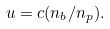Convert formula to latex. <formula><loc_0><loc_0><loc_500><loc_500>u = c ( n _ { b } / n _ { p } ) .</formula> 